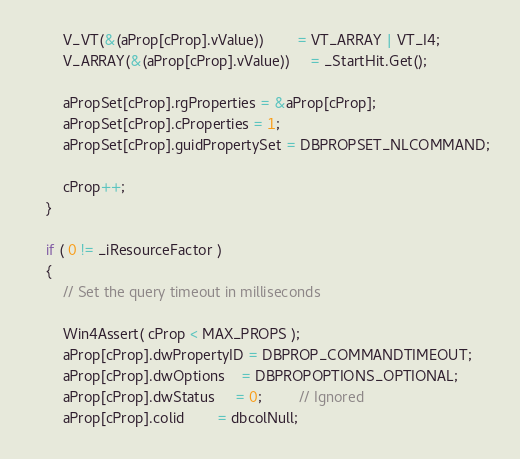Convert code to text. <code><loc_0><loc_0><loc_500><loc_500><_C++_>        V_VT(&(aProp[cProp].vValue))        = VT_ARRAY | VT_I4;
        V_ARRAY(&(aProp[cProp].vValue))     = _StartHit.Get();

        aPropSet[cProp].rgProperties = &aProp[cProp];
        aPropSet[cProp].cProperties = 1;
        aPropSet[cProp].guidPropertySet = DBPROPSET_NLCOMMAND;

        cProp++;
    }

    if ( 0 != _iResourceFactor )
    {
        // Set the query timeout in milliseconds

        Win4Assert( cProp < MAX_PROPS );
        aProp[cProp].dwPropertyID = DBPROP_COMMANDTIMEOUT;
        aProp[cProp].dwOptions    = DBPROPOPTIONS_OPTIONAL;
        aProp[cProp].dwStatus     = 0;         // Ignored
        aProp[cProp].colid        = dbcolNull;</code> 